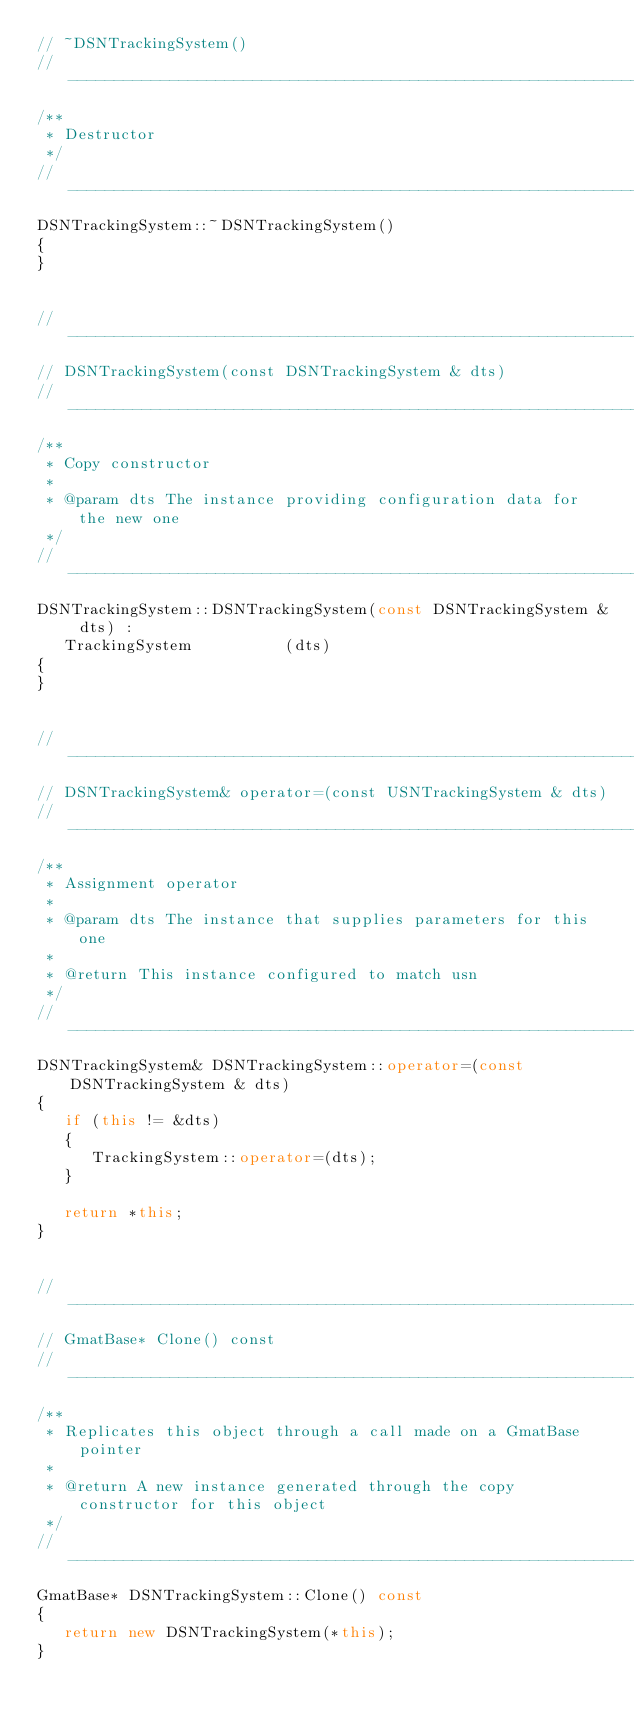<code> <loc_0><loc_0><loc_500><loc_500><_C++_>// ~DSNTrackingSystem()
//------------------------------------------------------------------------------
/**
 * Destructor
 */
//------------------------------------------------------------------------------
DSNTrackingSystem::~DSNTrackingSystem()
{
}


//------------------------------------------------------------------------------
// DSNTrackingSystem(const DSNTrackingSystem & dts)
//------------------------------------------------------------------------------
/**
 * Copy constructor
 *
 * @param dts The instance providing configuration data for the new one
 */
//------------------------------------------------------------------------------
DSNTrackingSystem::DSNTrackingSystem(const DSNTrackingSystem & dts) :
   TrackingSystem          (dts)
{
}


//------------------------------------------------------------------------------
// DSNTrackingSystem& operator=(const USNTrackingSystem & dts)
//------------------------------------------------------------------------------
/**
 * Assignment operator
 *
 * @param dts The instance that supplies parameters for this one
 *
 * @return This instance configured to match usn
 */
//------------------------------------------------------------------------------
DSNTrackingSystem& DSNTrackingSystem::operator=(const DSNTrackingSystem & dts)
{
   if (this != &dts)
   {
      TrackingSystem::operator=(dts);
   }

   return *this;
}


//------------------------------------------------------------------------------
// GmatBase* Clone() const
//------------------------------------------------------------------------------
/**
 * Replicates this object through a call made on a GmatBase pointer
 *
 * @return A new instance generated through the copy constructor for this object
 */
//------------------------------------------------------------------------------
GmatBase* DSNTrackingSystem::Clone() const
{
   return new DSNTrackingSystem(*this);
}
</code> 